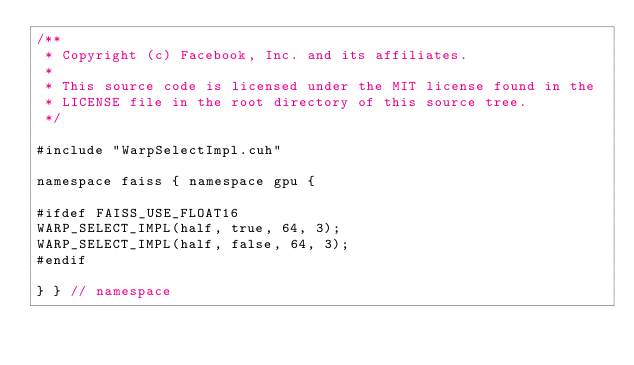<code> <loc_0><loc_0><loc_500><loc_500><_Cuda_>/**
 * Copyright (c) Facebook, Inc. and its affiliates.
 *
 * This source code is licensed under the MIT license found in the
 * LICENSE file in the root directory of this source tree.
 */

#include "WarpSelectImpl.cuh"

namespace faiss { namespace gpu {

#ifdef FAISS_USE_FLOAT16
WARP_SELECT_IMPL(half, true, 64, 3);
WARP_SELECT_IMPL(half, false, 64, 3);
#endif

} } // namespace
</code> 